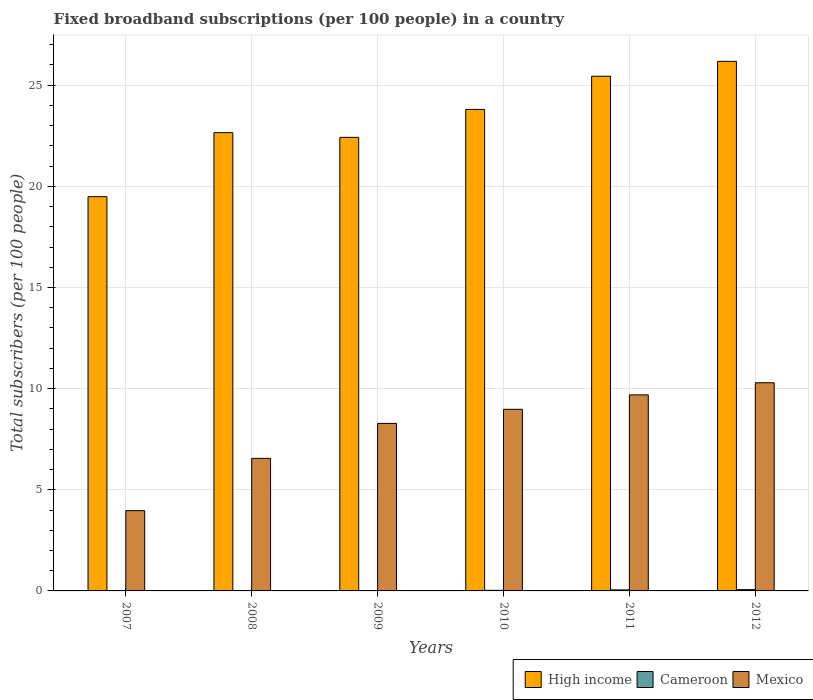How many different coloured bars are there?
Ensure brevity in your answer.  3. How many groups of bars are there?
Provide a short and direct response. 6. Are the number of bars per tick equal to the number of legend labels?
Your response must be concise. Yes. What is the label of the 6th group of bars from the left?
Provide a short and direct response. 2012. In how many cases, is the number of bars for a given year not equal to the number of legend labels?
Ensure brevity in your answer.  0. What is the number of broadband subscriptions in Mexico in 2007?
Your answer should be very brief. 3.97. Across all years, what is the maximum number of broadband subscriptions in Cameroon?
Your answer should be very brief. 0.06. Across all years, what is the minimum number of broadband subscriptions in High income?
Give a very brief answer. 19.49. In which year was the number of broadband subscriptions in Cameroon maximum?
Your answer should be very brief. 2012. In which year was the number of broadband subscriptions in Mexico minimum?
Your answer should be compact. 2007. What is the total number of broadband subscriptions in Cameroon in the graph?
Ensure brevity in your answer.  0.16. What is the difference between the number of broadband subscriptions in Mexico in 2008 and that in 2010?
Offer a very short reply. -2.43. What is the difference between the number of broadband subscriptions in Cameroon in 2009 and the number of broadband subscriptions in High income in 2012?
Your response must be concise. -26.17. What is the average number of broadband subscriptions in High income per year?
Provide a short and direct response. 23.33. In the year 2007, what is the difference between the number of broadband subscriptions in Mexico and number of broadband subscriptions in High income?
Your answer should be compact. -15.52. What is the ratio of the number of broadband subscriptions in Cameroon in 2008 to that in 2011?
Keep it short and to the point. 0.09. Is the difference between the number of broadband subscriptions in Mexico in 2007 and 2012 greater than the difference between the number of broadband subscriptions in High income in 2007 and 2012?
Give a very brief answer. Yes. What is the difference between the highest and the second highest number of broadband subscriptions in Cameroon?
Give a very brief answer. 0.01. What is the difference between the highest and the lowest number of broadband subscriptions in High income?
Make the answer very short. 6.69. What does the 3rd bar from the left in 2010 represents?
Your answer should be very brief. Mexico. Is it the case that in every year, the sum of the number of broadband subscriptions in Mexico and number of broadband subscriptions in Cameroon is greater than the number of broadband subscriptions in High income?
Offer a terse response. No. How many bars are there?
Offer a very short reply. 18. How many years are there in the graph?
Give a very brief answer. 6. Are the values on the major ticks of Y-axis written in scientific E-notation?
Keep it short and to the point. No. Does the graph contain grids?
Your response must be concise. Yes. How are the legend labels stacked?
Provide a short and direct response. Horizontal. What is the title of the graph?
Give a very brief answer. Fixed broadband subscriptions (per 100 people) in a country. Does "Madagascar" appear as one of the legend labels in the graph?
Your response must be concise. No. What is the label or title of the Y-axis?
Provide a short and direct response. Total subscribers (per 100 people). What is the Total subscribers (per 100 people) in High income in 2007?
Your answer should be very brief. 19.49. What is the Total subscribers (per 100 people) of Cameroon in 2007?
Provide a succinct answer. 0. What is the Total subscribers (per 100 people) of Mexico in 2007?
Keep it short and to the point. 3.97. What is the Total subscribers (per 100 people) of High income in 2008?
Provide a short and direct response. 22.65. What is the Total subscribers (per 100 people) of Cameroon in 2008?
Ensure brevity in your answer.  0. What is the Total subscribers (per 100 people) in Mexico in 2008?
Offer a very short reply. 6.55. What is the Total subscribers (per 100 people) in High income in 2009?
Make the answer very short. 22.42. What is the Total subscribers (per 100 people) of Cameroon in 2009?
Ensure brevity in your answer.  0. What is the Total subscribers (per 100 people) of Mexico in 2009?
Ensure brevity in your answer.  8.28. What is the Total subscribers (per 100 people) of High income in 2010?
Your answer should be compact. 23.8. What is the Total subscribers (per 100 people) of Cameroon in 2010?
Make the answer very short. 0.03. What is the Total subscribers (per 100 people) in Mexico in 2010?
Offer a very short reply. 8.98. What is the Total subscribers (per 100 people) of High income in 2011?
Offer a terse response. 25.44. What is the Total subscribers (per 100 people) in Cameroon in 2011?
Provide a short and direct response. 0.05. What is the Total subscribers (per 100 people) in Mexico in 2011?
Provide a short and direct response. 9.69. What is the Total subscribers (per 100 people) in High income in 2012?
Give a very brief answer. 26.18. What is the Total subscribers (per 100 people) in Cameroon in 2012?
Keep it short and to the point. 0.06. What is the Total subscribers (per 100 people) in Mexico in 2012?
Give a very brief answer. 10.29. Across all years, what is the maximum Total subscribers (per 100 people) in High income?
Provide a short and direct response. 26.18. Across all years, what is the maximum Total subscribers (per 100 people) of Cameroon?
Your answer should be compact. 0.06. Across all years, what is the maximum Total subscribers (per 100 people) of Mexico?
Make the answer very short. 10.29. Across all years, what is the minimum Total subscribers (per 100 people) of High income?
Offer a very short reply. 19.49. Across all years, what is the minimum Total subscribers (per 100 people) of Cameroon?
Offer a terse response. 0. Across all years, what is the minimum Total subscribers (per 100 people) in Mexico?
Provide a short and direct response. 3.97. What is the total Total subscribers (per 100 people) in High income in the graph?
Provide a short and direct response. 139.98. What is the total Total subscribers (per 100 people) of Cameroon in the graph?
Your answer should be compact. 0.16. What is the total Total subscribers (per 100 people) in Mexico in the graph?
Offer a very short reply. 47.76. What is the difference between the Total subscribers (per 100 people) in High income in 2007 and that in 2008?
Your answer should be compact. -3.16. What is the difference between the Total subscribers (per 100 people) in Cameroon in 2007 and that in 2008?
Your response must be concise. -0. What is the difference between the Total subscribers (per 100 people) in Mexico in 2007 and that in 2008?
Offer a very short reply. -2.58. What is the difference between the Total subscribers (per 100 people) of High income in 2007 and that in 2009?
Provide a short and direct response. -2.93. What is the difference between the Total subscribers (per 100 people) of Cameroon in 2007 and that in 2009?
Make the answer very short. -0. What is the difference between the Total subscribers (per 100 people) in Mexico in 2007 and that in 2009?
Provide a short and direct response. -4.31. What is the difference between the Total subscribers (per 100 people) in High income in 2007 and that in 2010?
Make the answer very short. -4.31. What is the difference between the Total subscribers (per 100 people) of Cameroon in 2007 and that in 2010?
Provide a succinct answer. -0.03. What is the difference between the Total subscribers (per 100 people) in Mexico in 2007 and that in 2010?
Your answer should be compact. -5.01. What is the difference between the Total subscribers (per 100 people) of High income in 2007 and that in 2011?
Your answer should be very brief. -5.95. What is the difference between the Total subscribers (per 100 people) in Cameroon in 2007 and that in 2011?
Give a very brief answer. -0.05. What is the difference between the Total subscribers (per 100 people) in Mexico in 2007 and that in 2011?
Provide a short and direct response. -5.72. What is the difference between the Total subscribers (per 100 people) of High income in 2007 and that in 2012?
Offer a terse response. -6.69. What is the difference between the Total subscribers (per 100 people) of Cameroon in 2007 and that in 2012?
Provide a short and direct response. -0.06. What is the difference between the Total subscribers (per 100 people) of Mexico in 2007 and that in 2012?
Your answer should be very brief. -6.32. What is the difference between the Total subscribers (per 100 people) in High income in 2008 and that in 2009?
Provide a succinct answer. 0.23. What is the difference between the Total subscribers (per 100 people) of Cameroon in 2008 and that in 2009?
Make the answer very short. -0. What is the difference between the Total subscribers (per 100 people) of Mexico in 2008 and that in 2009?
Provide a succinct answer. -1.73. What is the difference between the Total subscribers (per 100 people) in High income in 2008 and that in 2010?
Offer a very short reply. -1.15. What is the difference between the Total subscribers (per 100 people) in Cameroon in 2008 and that in 2010?
Offer a very short reply. -0.02. What is the difference between the Total subscribers (per 100 people) in Mexico in 2008 and that in 2010?
Give a very brief answer. -2.43. What is the difference between the Total subscribers (per 100 people) in High income in 2008 and that in 2011?
Your answer should be very brief. -2.79. What is the difference between the Total subscribers (per 100 people) in Cameroon in 2008 and that in 2011?
Your response must be concise. -0.05. What is the difference between the Total subscribers (per 100 people) of Mexico in 2008 and that in 2011?
Your response must be concise. -3.14. What is the difference between the Total subscribers (per 100 people) of High income in 2008 and that in 2012?
Give a very brief answer. -3.52. What is the difference between the Total subscribers (per 100 people) in Cameroon in 2008 and that in 2012?
Make the answer very short. -0.06. What is the difference between the Total subscribers (per 100 people) in Mexico in 2008 and that in 2012?
Your answer should be very brief. -3.74. What is the difference between the Total subscribers (per 100 people) in High income in 2009 and that in 2010?
Keep it short and to the point. -1.38. What is the difference between the Total subscribers (per 100 people) of Cameroon in 2009 and that in 2010?
Offer a very short reply. -0.02. What is the difference between the Total subscribers (per 100 people) of Mexico in 2009 and that in 2010?
Give a very brief answer. -0.7. What is the difference between the Total subscribers (per 100 people) of High income in 2009 and that in 2011?
Your answer should be very brief. -3.02. What is the difference between the Total subscribers (per 100 people) in Cameroon in 2009 and that in 2011?
Ensure brevity in your answer.  -0.05. What is the difference between the Total subscribers (per 100 people) in Mexico in 2009 and that in 2011?
Provide a short and direct response. -1.41. What is the difference between the Total subscribers (per 100 people) of High income in 2009 and that in 2012?
Offer a terse response. -3.76. What is the difference between the Total subscribers (per 100 people) in Cameroon in 2009 and that in 2012?
Give a very brief answer. -0.06. What is the difference between the Total subscribers (per 100 people) of Mexico in 2009 and that in 2012?
Provide a short and direct response. -2.01. What is the difference between the Total subscribers (per 100 people) of High income in 2010 and that in 2011?
Give a very brief answer. -1.64. What is the difference between the Total subscribers (per 100 people) of Cameroon in 2010 and that in 2011?
Provide a succinct answer. -0.02. What is the difference between the Total subscribers (per 100 people) in Mexico in 2010 and that in 2011?
Keep it short and to the point. -0.71. What is the difference between the Total subscribers (per 100 people) in High income in 2010 and that in 2012?
Provide a short and direct response. -2.38. What is the difference between the Total subscribers (per 100 people) in Cameroon in 2010 and that in 2012?
Offer a very short reply. -0.03. What is the difference between the Total subscribers (per 100 people) of Mexico in 2010 and that in 2012?
Your response must be concise. -1.31. What is the difference between the Total subscribers (per 100 people) of High income in 2011 and that in 2012?
Your answer should be compact. -0.74. What is the difference between the Total subscribers (per 100 people) in Cameroon in 2011 and that in 2012?
Your response must be concise. -0.01. What is the difference between the Total subscribers (per 100 people) of Mexico in 2011 and that in 2012?
Your answer should be compact. -0.6. What is the difference between the Total subscribers (per 100 people) in High income in 2007 and the Total subscribers (per 100 people) in Cameroon in 2008?
Your answer should be compact. 19.48. What is the difference between the Total subscribers (per 100 people) in High income in 2007 and the Total subscribers (per 100 people) in Mexico in 2008?
Your answer should be very brief. 12.94. What is the difference between the Total subscribers (per 100 people) of Cameroon in 2007 and the Total subscribers (per 100 people) of Mexico in 2008?
Your answer should be compact. -6.55. What is the difference between the Total subscribers (per 100 people) of High income in 2007 and the Total subscribers (per 100 people) of Cameroon in 2009?
Offer a very short reply. 19.48. What is the difference between the Total subscribers (per 100 people) in High income in 2007 and the Total subscribers (per 100 people) in Mexico in 2009?
Offer a very short reply. 11.21. What is the difference between the Total subscribers (per 100 people) in Cameroon in 2007 and the Total subscribers (per 100 people) in Mexico in 2009?
Your response must be concise. -8.28. What is the difference between the Total subscribers (per 100 people) in High income in 2007 and the Total subscribers (per 100 people) in Cameroon in 2010?
Give a very brief answer. 19.46. What is the difference between the Total subscribers (per 100 people) of High income in 2007 and the Total subscribers (per 100 people) of Mexico in 2010?
Offer a very short reply. 10.51. What is the difference between the Total subscribers (per 100 people) in Cameroon in 2007 and the Total subscribers (per 100 people) in Mexico in 2010?
Offer a terse response. -8.97. What is the difference between the Total subscribers (per 100 people) of High income in 2007 and the Total subscribers (per 100 people) of Cameroon in 2011?
Give a very brief answer. 19.44. What is the difference between the Total subscribers (per 100 people) in High income in 2007 and the Total subscribers (per 100 people) in Mexico in 2011?
Ensure brevity in your answer.  9.8. What is the difference between the Total subscribers (per 100 people) in Cameroon in 2007 and the Total subscribers (per 100 people) in Mexico in 2011?
Your answer should be compact. -9.69. What is the difference between the Total subscribers (per 100 people) of High income in 2007 and the Total subscribers (per 100 people) of Cameroon in 2012?
Offer a very short reply. 19.42. What is the difference between the Total subscribers (per 100 people) of High income in 2007 and the Total subscribers (per 100 people) of Mexico in 2012?
Provide a short and direct response. 9.2. What is the difference between the Total subscribers (per 100 people) of Cameroon in 2007 and the Total subscribers (per 100 people) of Mexico in 2012?
Provide a short and direct response. -10.29. What is the difference between the Total subscribers (per 100 people) in High income in 2008 and the Total subscribers (per 100 people) in Cameroon in 2009?
Your answer should be compact. 22.65. What is the difference between the Total subscribers (per 100 people) in High income in 2008 and the Total subscribers (per 100 people) in Mexico in 2009?
Offer a very short reply. 14.37. What is the difference between the Total subscribers (per 100 people) of Cameroon in 2008 and the Total subscribers (per 100 people) of Mexico in 2009?
Keep it short and to the point. -8.28. What is the difference between the Total subscribers (per 100 people) of High income in 2008 and the Total subscribers (per 100 people) of Cameroon in 2010?
Keep it short and to the point. 22.62. What is the difference between the Total subscribers (per 100 people) of High income in 2008 and the Total subscribers (per 100 people) of Mexico in 2010?
Your response must be concise. 13.68. What is the difference between the Total subscribers (per 100 people) in Cameroon in 2008 and the Total subscribers (per 100 people) in Mexico in 2010?
Offer a terse response. -8.97. What is the difference between the Total subscribers (per 100 people) in High income in 2008 and the Total subscribers (per 100 people) in Cameroon in 2011?
Your answer should be compact. 22.6. What is the difference between the Total subscribers (per 100 people) of High income in 2008 and the Total subscribers (per 100 people) of Mexico in 2011?
Provide a short and direct response. 12.96. What is the difference between the Total subscribers (per 100 people) in Cameroon in 2008 and the Total subscribers (per 100 people) in Mexico in 2011?
Your answer should be very brief. -9.69. What is the difference between the Total subscribers (per 100 people) in High income in 2008 and the Total subscribers (per 100 people) in Cameroon in 2012?
Offer a terse response. 22.59. What is the difference between the Total subscribers (per 100 people) in High income in 2008 and the Total subscribers (per 100 people) in Mexico in 2012?
Keep it short and to the point. 12.36. What is the difference between the Total subscribers (per 100 people) of Cameroon in 2008 and the Total subscribers (per 100 people) of Mexico in 2012?
Offer a terse response. -10.28. What is the difference between the Total subscribers (per 100 people) in High income in 2009 and the Total subscribers (per 100 people) in Cameroon in 2010?
Keep it short and to the point. 22.39. What is the difference between the Total subscribers (per 100 people) of High income in 2009 and the Total subscribers (per 100 people) of Mexico in 2010?
Offer a very short reply. 13.44. What is the difference between the Total subscribers (per 100 people) of Cameroon in 2009 and the Total subscribers (per 100 people) of Mexico in 2010?
Your answer should be compact. -8.97. What is the difference between the Total subscribers (per 100 people) of High income in 2009 and the Total subscribers (per 100 people) of Cameroon in 2011?
Provide a short and direct response. 22.37. What is the difference between the Total subscribers (per 100 people) in High income in 2009 and the Total subscribers (per 100 people) in Mexico in 2011?
Give a very brief answer. 12.73. What is the difference between the Total subscribers (per 100 people) in Cameroon in 2009 and the Total subscribers (per 100 people) in Mexico in 2011?
Keep it short and to the point. -9.69. What is the difference between the Total subscribers (per 100 people) in High income in 2009 and the Total subscribers (per 100 people) in Cameroon in 2012?
Make the answer very short. 22.36. What is the difference between the Total subscribers (per 100 people) of High income in 2009 and the Total subscribers (per 100 people) of Mexico in 2012?
Your answer should be very brief. 12.13. What is the difference between the Total subscribers (per 100 people) of Cameroon in 2009 and the Total subscribers (per 100 people) of Mexico in 2012?
Offer a very short reply. -10.28. What is the difference between the Total subscribers (per 100 people) of High income in 2010 and the Total subscribers (per 100 people) of Cameroon in 2011?
Ensure brevity in your answer.  23.75. What is the difference between the Total subscribers (per 100 people) of High income in 2010 and the Total subscribers (per 100 people) of Mexico in 2011?
Keep it short and to the point. 14.11. What is the difference between the Total subscribers (per 100 people) in Cameroon in 2010 and the Total subscribers (per 100 people) in Mexico in 2011?
Your response must be concise. -9.66. What is the difference between the Total subscribers (per 100 people) of High income in 2010 and the Total subscribers (per 100 people) of Cameroon in 2012?
Provide a succinct answer. 23.74. What is the difference between the Total subscribers (per 100 people) in High income in 2010 and the Total subscribers (per 100 people) in Mexico in 2012?
Provide a succinct answer. 13.51. What is the difference between the Total subscribers (per 100 people) of Cameroon in 2010 and the Total subscribers (per 100 people) of Mexico in 2012?
Provide a short and direct response. -10.26. What is the difference between the Total subscribers (per 100 people) in High income in 2011 and the Total subscribers (per 100 people) in Cameroon in 2012?
Provide a short and direct response. 25.38. What is the difference between the Total subscribers (per 100 people) in High income in 2011 and the Total subscribers (per 100 people) in Mexico in 2012?
Your response must be concise. 15.15. What is the difference between the Total subscribers (per 100 people) of Cameroon in 2011 and the Total subscribers (per 100 people) of Mexico in 2012?
Provide a succinct answer. -10.24. What is the average Total subscribers (per 100 people) in High income per year?
Make the answer very short. 23.33. What is the average Total subscribers (per 100 people) in Cameroon per year?
Keep it short and to the point. 0.03. What is the average Total subscribers (per 100 people) of Mexico per year?
Your answer should be very brief. 7.96. In the year 2007, what is the difference between the Total subscribers (per 100 people) in High income and Total subscribers (per 100 people) in Cameroon?
Provide a short and direct response. 19.49. In the year 2007, what is the difference between the Total subscribers (per 100 people) of High income and Total subscribers (per 100 people) of Mexico?
Offer a terse response. 15.52. In the year 2007, what is the difference between the Total subscribers (per 100 people) of Cameroon and Total subscribers (per 100 people) of Mexico?
Your answer should be very brief. -3.96. In the year 2008, what is the difference between the Total subscribers (per 100 people) of High income and Total subscribers (per 100 people) of Cameroon?
Your response must be concise. 22.65. In the year 2008, what is the difference between the Total subscribers (per 100 people) in High income and Total subscribers (per 100 people) in Mexico?
Your response must be concise. 16.1. In the year 2008, what is the difference between the Total subscribers (per 100 people) of Cameroon and Total subscribers (per 100 people) of Mexico?
Provide a succinct answer. -6.55. In the year 2009, what is the difference between the Total subscribers (per 100 people) of High income and Total subscribers (per 100 people) of Cameroon?
Provide a succinct answer. 22.42. In the year 2009, what is the difference between the Total subscribers (per 100 people) of High income and Total subscribers (per 100 people) of Mexico?
Keep it short and to the point. 14.14. In the year 2009, what is the difference between the Total subscribers (per 100 people) of Cameroon and Total subscribers (per 100 people) of Mexico?
Offer a terse response. -8.28. In the year 2010, what is the difference between the Total subscribers (per 100 people) in High income and Total subscribers (per 100 people) in Cameroon?
Offer a very short reply. 23.77. In the year 2010, what is the difference between the Total subscribers (per 100 people) in High income and Total subscribers (per 100 people) in Mexico?
Provide a short and direct response. 14.82. In the year 2010, what is the difference between the Total subscribers (per 100 people) of Cameroon and Total subscribers (per 100 people) of Mexico?
Provide a short and direct response. -8.95. In the year 2011, what is the difference between the Total subscribers (per 100 people) of High income and Total subscribers (per 100 people) of Cameroon?
Your response must be concise. 25.39. In the year 2011, what is the difference between the Total subscribers (per 100 people) in High income and Total subscribers (per 100 people) in Mexico?
Provide a succinct answer. 15.75. In the year 2011, what is the difference between the Total subscribers (per 100 people) of Cameroon and Total subscribers (per 100 people) of Mexico?
Your answer should be very brief. -9.64. In the year 2012, what is the difference between the Total subscribers (per 100 people) in High income and Total subscribers (per 100 people) in Cameroon?
Provide a succinct answer. 26.11. In the year 2012, what is the difference between the Total subscribers (per 100 people) in High income and Total subscribers (per 100 people) in Mexico?
Give a very brief answer. 15.89. In the year 2012, what is the difference between the Total subscribers (per 100 people) of Cameroon and Total subscribers (per 100 people) of Mexico?
Provide a short and direct response. -10.23. What is the ratio of the Total subscribers (per 100 people) of High income in 2007 to that in 2008?
Keep it short and to the point. 0.86. What is the ratio of the Total subscribers (per 100 people) of Cameroon in 2007 to that in 2008?
Give a very brief answer. 0.76. What is the ratio of the Total subscribers (per 100 people) in Mexico in 2007 to that in 2008?
Your response must be concise. 0.61. What is the ratio of the Total subscribers (per 100 people) in High income in 2007 to that in 2009?
Provide a succinct answer. 0.87. What is the ratio of the Total subscribers (per 100 people) of Cameroon in 2007 to that in 2009?
Give a very brief answer. 0.75. What is the ratio of the Total subscribers (per 100 people) in Mexico in 2007 to that in 2009?
Offer a terse response. 0.48. What is the ratio of the Total subscribers (per 100 people) in High income in 2007 to that in 2010?
Ensure brevity in your answer.  0.82. What is the ratio of the Total subscribers (per 100 people) of Cameroon in 2007 to that in 2010?
Keep it short and to the point. 0.12. What is the ratio of the Total subscribers (per 100 people) in Mexico in 2007 to that in 2010?
Make the answer very short. 0.44. What is the ratio of the Total subscribers (per 100 people) of High income in 2007 to that in 2011?
Your response must be concise. 0.77. What is the ratio of the Total subscribers (per 100 people) of Cameroon in 2007 to that in 2011?
Offer a very short reply. 0.07. What is the ratio of the Total subscribers (per 100 people) in Mexico in 2007 to that in 2011?
Your response must be concise. 0.41. What is the ratio of the Total subscribers (per 100 people) of High income in 2007 to that in 2012?
Offer a very short reply. 0.74. What is the ratio of the Total subscribers (per 100 people) of Cameroon in 2007 to that in 2012?
Keep it short and to the point. 0.05. What is the ratio of the Total subscribers (per 100 people) in Mexico in 2007 to that in 2012?
Provide a succinct answer. 0.39. What is the ratio of the Total subscribers (per 100 people) in High income in 2008 to that in 2009?
Your answer should be compact. 1.01. What is the ratio of the Total subscribers (per 100 people) of Cameroon in 2008 to that in 2009?
Offer a very short reply. 0.98. What is the ratio of the Total subscribers (per 100 people) of Mexico in 2008 to that in 2009?
Provide a succinct answer. 0.79. What is the ratio of the Total subscribers (per 100 people) of High income in 2008 to that in 2010?
Make the answer very short. 0.95. What is the ratio of the Total subscribers (per 100 people) of Cameroon in 2008 to that in 2010?
Make the answer very short. 0.15. What is the ratio of the Total subscribers (per 100 people) of Mexico in 2008 to that in 2010?
Keep it short and to the point. 0.73. What is the ratio of the Total subscribers (per 100 people) in High income in 2008 to that in 2011?
Give a very brief answer. 0.89. What is the ratio of the Total subscribers (per 100 people) of Cameroon in 2008 to that in 2011?
Your answer should be compact. 0.09. What is the ratio of the Total subscribers (per 100 people) of Mexico in 2008 to that in 2011?
Ensure brevity in your answer.  0.68. What is the ratio of the Total subscribers (per 100 people) in High income in 2008 to that in 2012?
Your response must be concise. 0.87. What is the ratio of the Total subscribers (per 100 people) in Cameroon in 2008 to that in 2012?
Give a very brief answer. 0.07. What is the ratio of the Total subscribers (per 100 people) of Mexico in 2008 to that in 2012?
Your answer should be compact. 0.64. What is the ratio of the Total subscribers (per 100 people) in High income in 2009 to that in 2010?
Your response must be concise. 0.94. What is the ratio of the Total subscribers (per 100 people) of Cameroon in 2009 to that in 2010?
Make the answer very short. 0.16. What is the ratio of the Total subscribers (per 100 people) in Mexico in 2009 to that in 2010?
Keep it short and to the point. 0.92. What is the ratio of the Total subscribers (per 100 people) in High income in 2009 to that in 2011?
Your response must be concise. 0.88. What is the ratio of the Total subscribers (per 100 people) of Cameroon in 2009 to that in 2011?
Make the answer very short. 0.09. What is the ratio of the Total subscribers (per 100 people) of Mexico in 2009 to that in 2011?
Your answer should be compact. 0.85. What is the ratio of the Total subscribers (per 100 people) in High income in 2009 to that in 2012?
Keep it short and to the point. 0.86. What is the ratio of the Total subscribers (per 100 people) in Cameroon in 2009 to that in 2012?
Offer a very short reply. 0.07. What is the ratio of the Total subscribers (per 100 people) of Mexico in 2009 to that in 2012?
Make the answer very short. 0.8. What is the ratio of the Total subscribers (per 100 people) of High income in 2010 to that in 2011?
Give a very brief answer. 0.94. What is the ratio of the Total subscribers (per 100 people) in Cameroon in 2010 to that in 2011?
Offer a terse response. 0.57. What is the ratio of the Total subscribers (per 100 people) in Mexico in 2010 to that in 2011?
Ensure brevity in your answer.  0.93. What is the ratio of the Total subscribers (per 100 people) of High income in 2010 to that in 2012?
Offer a terse response. 0.91. What is the ratio of the Total subscribers (per 100 people) of Cameroon in 2010 to that in 2012?
Provide a short and direct response. 0.45. What is the ratio of the Total subscribers (per 100 people) in Mexico in 2010 to that in 2012?
Your response must be concise. 0.87. What is the ratio of the Total subscribers (per 100 people) of High income in 2011 to that in 2012?
Provide a succinct answer. 0.97. What is the ratio of the Total subscribers (per 100 people) of Cameroon in 2011 to that in 2012?
Ensure brevity in your answer.  0.79. What is the ratio of the Total subscribers (per 100 people) in Mexico in 2011 to that in 2012?
Your answer should be very brief. 0.94. What is the difference between the highest and the second highest Total subscribers (per 100 people) of High income?
Ensure brevity in your answer.  0.74. What is the difference between the highest and the second highest Total subscribers (per 100 people) of Cameroon?
Offer a very short reply. 0.01. What is the difference between the highest and the second highest Total subscribers (per 100 people) in Mexico?
Make the answer very short. 0.6. What is the difference between the highest and the lowest Total subscribers (per 100 people) in High income?
Make the answer very short. 6.69. What is the difference between the highest and the lowest Total subscribers (per 100 people) of Cameroon?
Offer a very short reply. 0.06. What is the difference between the highest and the lowest Total subscribers (per 100 people) of Mexico?
Your answer should be compact. 6.32. 